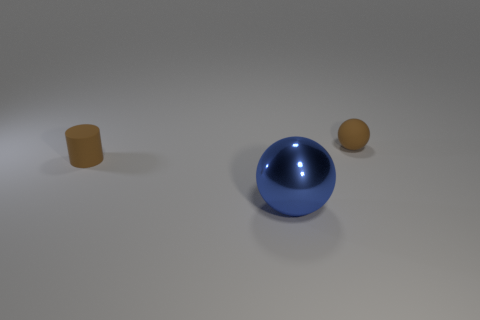There is a blue thing; does it have the same shape as the small object to the right of the large blue thing?
Keep it short and to the point. Yes. What number of things are either small brown things that are to the right of the large shiny object or matte things that are behind the small brown cylinder?
Provide a succinct answer. 1. What is the material of the small cylinder?
Provide a short and direct response. Rubber. What number of other objects are there of the same size as the metal ball?
Your answer should be compact. 0. What size is the ball in front of the small cylinder?
Give a very brief answer. Large. There is a tiny brown object in front of the small matte object on the right side of the small rubber thing that is left of the small brown matte ball; what is it made of?
Your answer should be compact. Rubber. How many metallic things are large green cubes or small brown objects?
Keep it short and to the point. 0. What number of big green cylinders are there?
Your response must be concise. 0. There is a sphere that is the same size as the cylinder; what is its color?
Your answer should be very brief. Brown. Do the brown rubber ball and the brown matte cylinder have the same size?
Provide a short and direct response. Yes. 